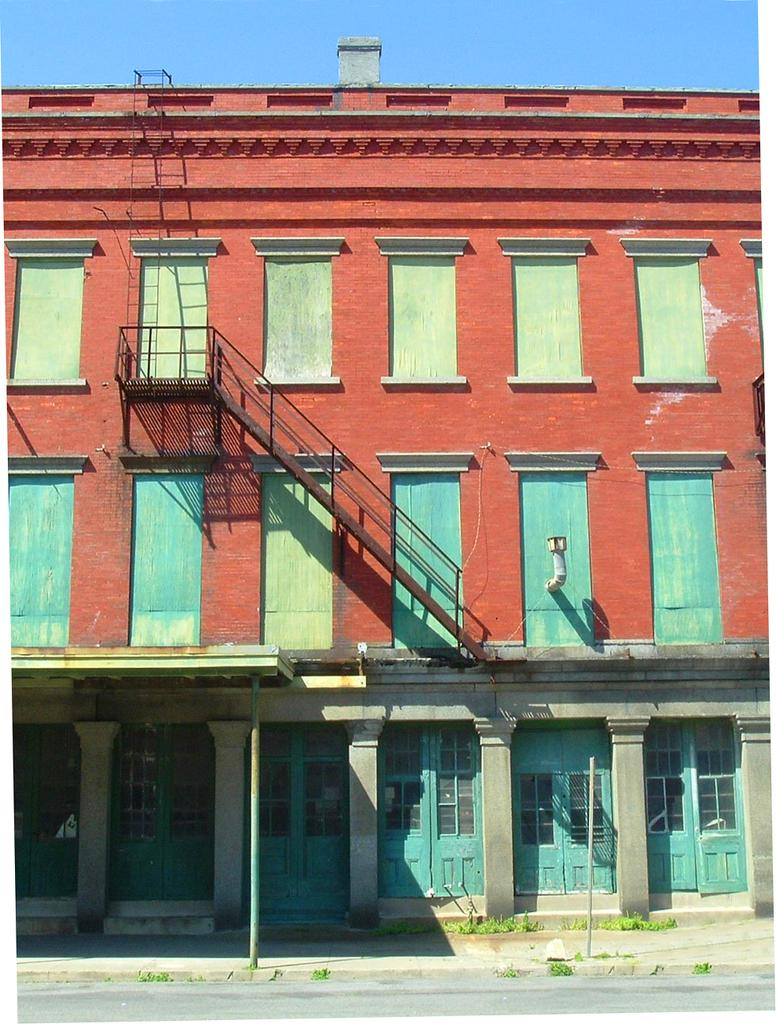What type of structure is visible in the image? There is a building in the image. How is the building positioned in the image? The image shows a front view of the building. What feature is present on the building? There is a metal staircase in the image. What is the purpose of the metal staircase? The metal staircase leads to the top of the building. What type of shop can be seen on the top floor of the building in the image? There is no shop visible on the top floor of the building in the image. What letter is written on the side of the building in the image? There is no letter visible on the side of the building in the image. 